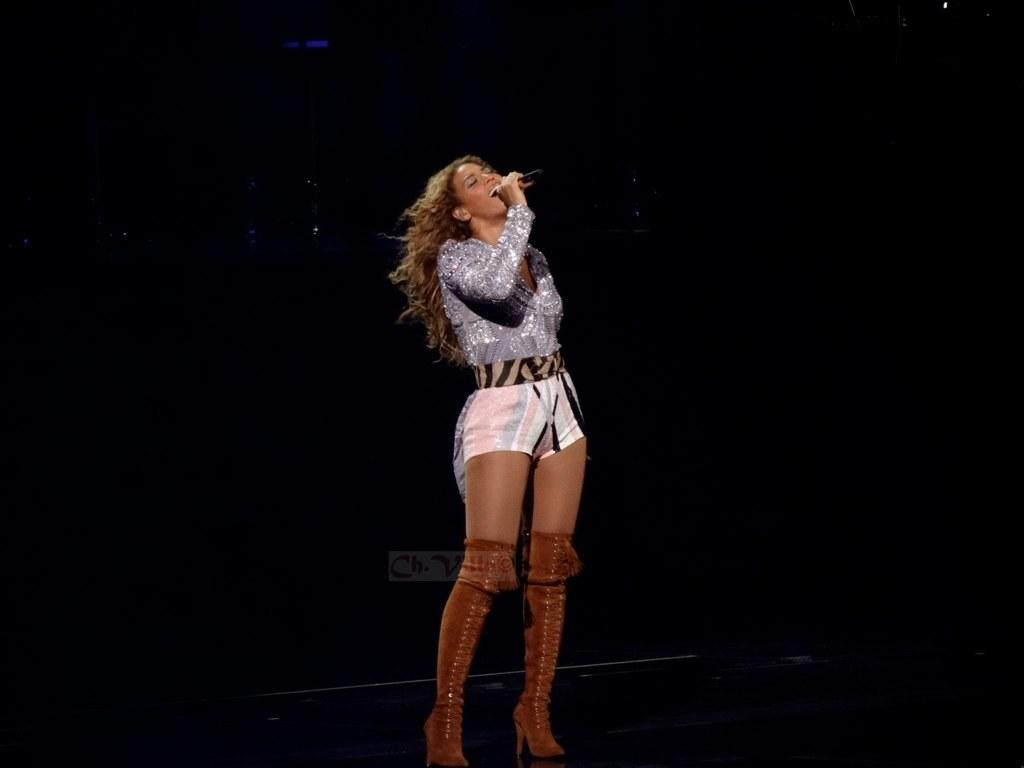What is the woman in the image doing? The woman is standing in the image and appears to be singing. What object is the woman holding in the image? The woman is holding a microphone in the image. Can you describe the background of the image? The background of the image is dark. What type of stitch is the woman using to sew a button on her shirt in the image? There is no indication in the image that the woman is sewing a button or using any type of stitch. 